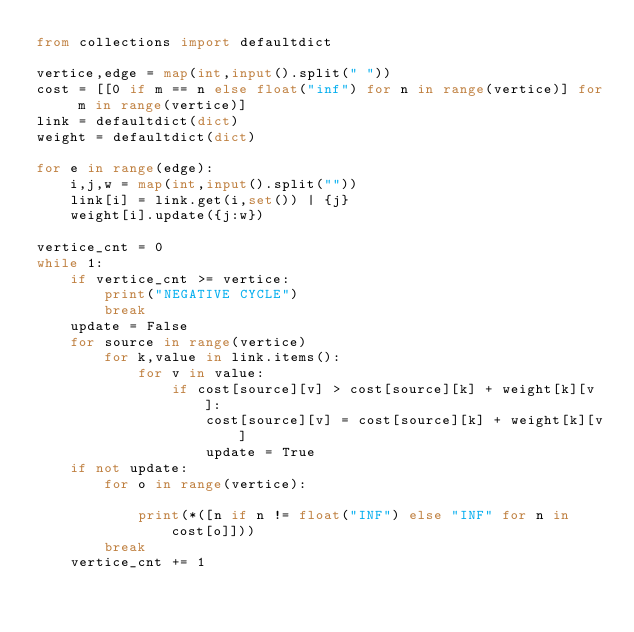Convert code to text. <code><loc_0><loc_0><loc_500><loc_500><_Python_>from collections import defaultdict

vertice,edge = map(int,input().split(" "))
cost = [[0 if m == n else float("inf") for n in range(vertice)] for m in range(vertice)]
link = defaultdict(dict)
weight = defaultdict(dict)

for e in range(edge):
    i,j,w = map(int,input().split(""))
    link[i] = link.get(i,set()) | {j}
    weight[i].update({j:w})

vertice_cnt = 0
while 1:
    if vertice_cnt >= vertice:
        print("NEGATIVE CYCLE")
        break
    update = False
    for source in range(vertice)
        for k,value in link.items():
            for v in value:
                if cost[source][v] > cost[source][k] + weight[k][v]:
                    cost[source][v] = cost[source][k] + weight[k][v]
                    update = True
    if not update:
        for o in range(vertice):

            print(*([n if n != float("INF") else "INF" for n in cost[o]]))
        break
    vertice_cnt += 1</code> 